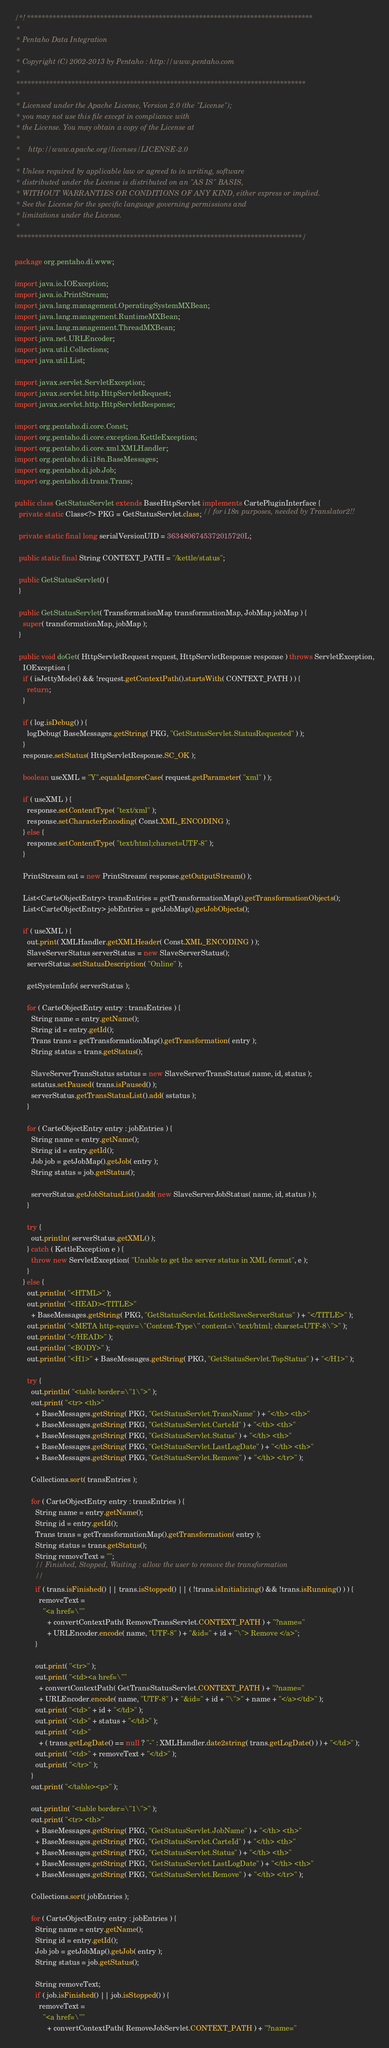<code> <loc_0><loc_0><loc_500><loc_500><_Java_>/*! ******************************************************************************
 *
 * Pentaho Data Integration
 *
 * Copyright (C) 2002-2013 by Pentaho : http://www.pentaho.com
 *
 *******************************************************************************
 *
 * Licensed under the Apache License, Version 2.0 (the "License");
 * you may not use this file except in compliance with
 * the License. You may obtain a copy of the License at
 *
 *    http://www.apache.org/licenses/LICENSE-2.0
 *
 * Unless required by applicable law or agreed to in writing, software
 * distributed under the License is distributed on an "AS IS" BASIS,
 * WITHOUT WARRANTIES OR CONDITIONS OF ANY KIND, either express or implied.
 * See the License for the specific language governing permissions and
 * limitations under the License.
 *
 ******************************************************************************/

package org.pentaho.di.www;

import java.io.IOException;
import java.io.PrintStream;
import java.lang.management.OperatingSystemMXBean;
import java.lang.management.RuntimeMXBean;
import java.lang.management.ThreadMXBean;
import java.net.URLEncoder;
import java.util.Collections;
import java.util.List;

import javax.servlet.ServletException;
import javax.servlet.http.HttpServletRequest;
import javax.servlet.http.HttpServletResponse;

import org.pentaho.di.core.Const;
import org.pentaho.di.core.exception.KettleException;
import org.pentaho.di.core.xml.XMLHandler;
import org.pentaho.di.i18n.BaseMessages;
import org.pentaho.di.job.Job;
import org.pentaho.di.trans.Trans;

public class GetStatusServlet extends BaseHttpServlet implements CartePluginInterface {
  private static Class<?> PKG = GetStatusServlet.class; // for i18n purposes, needed by Translator2!!

  private static final long serialVersionUID = 3634806745372015720L;

  public static final String CONTEXT_PATH = "/kettle/status";

  public GetStatusServlet() {
  }

  public GetStatusServlet( TransformationMap transformationMap, JobMap jobMap ) {
    super( transformationMap, jobMap );
  }

  public void doGet( HttpServletRequest request, HttpServletResponse response ) throws ServletException,
    IOException {
    if ( isJettyMode() && !request.getContextPath().startsWith( CONTEXT_PATH ) ) {
      return;
    }

    if ( log.isDebug() ) {
      logDebug( BaseMessages.getString( PKG, "GetStatusServlet.StatusRequested" ) );
    }
    response.setStatus( HttpServletResponse.SC_OK );

    boolean useXML = "Y".equalsIgnoreCase( request.getParameter( "xml" ) );

    if ( useXML ) {
      response.setContentType( "text/xml" );
      response.setCharacterEncoding( Const.XML_ENCODING );
    } else {
      response.setContentType( "text/html;charset=UTF-8" );
    }

    PrintStream out = new PrintStream( response.getOutputStream() );

    List<CarteObjectEntry> transEntries = getTransformationMap().getTransformationObjects();
    List<CarteObjectEntry> jobEntries = getJobMap().getJobObjects();

    if ( useXML ) {
      out.print( XMLHandler.getXMLHeader( Const.XML_ENCODING ) );
      SlaveServerStatus serverStatus = new SlaveServerStatus();
      serverStatus.setStatusDescription( "Online" );

      getSystemInfo( serverStatus );

      for ( CarteObjectEntry entry : transEntries ) {
        String name = entry.getName();
        String id = entry.getId();
        Trans trans = getTransformationMap().getTransformation( entry );
        String status = trans.getStatus();

        SlaveServerTransStatus sstatus = new SlaveServerTransStatus( name, id, status );
        sstatus.setPaused( trans.isPaused() );
        serverStatus.getTransStatusList().add( sstatus );
      }

      for ( CarteObjectEntry entry : jobEntries ) {
        String name = entry.getName();
        String id = entry.getId();
        Job job = getJobMap().getJob( entry );
        String status = job.getStatus();

        serverStatus.getJobStatusList().add( new SlaveServerJobStatus( name, id, status ) );
      }

      try {
        out.println( serverStatus.getXML() );
      } catch ( KettleException e ) {
        throw new ServletException( "Unable to get the server status in XML format", e );
      }
    } else {
      out.println( "<HTML>" );
      out.println( "<HEAD><TITLE>"
        + BaseMessages.getString( PKG, "GetStatusServlet.KettleSlaveServerStatus" ) + "</TITLE>" );
      out.println( "<META http-equiv=\"Content-Type\" content=\"text/html; charset=UTF-8\">" );
      out.println( "</HEAD>" );
      out.println( "<BODY>" );
      out.println( "<H1>" + BaseMessages.getString( PKG, "GetStatusServlet.TopStatus" ) + "</H1>" );

      try {
        out.println( "<table border=\"1\">" );
        out.print( "<tr> <th>"
          + BaseMessages.getString( PKG, "GetStatusServlet.TransName" ) + "</th> <th>"
          + BaseMessages.getString( PKG, "GetStatusServlet.CarteId" ) + "</th> <th>"
          + BaseMessages.getString( PKG, "GetStatusServlet.Status" ) + "</th> <th>"
          + BaseMessages.getString( PKG, "GetStatusServlet.LastLogDate" ) + "</th> <th>"
          + BaseMessages.getString( PKG, "GetStatusServlet.Remove" ) + "</th> </tr>" );

        Collections.sort( transEntries );

        for ( CarteObjectEntry entry : transEntries ) {
          String name = entry.getName();
          String id = entry.getId();
          Trans trans = getTransformationMap().getTransformation( entry );
          String status = trans.getStatus();
          String removeText = "";
          // Finished, Stopped, Waiting : allow the user to remove the transformation
          //
          if ( trans.isFinished() || trans.isStopped() || ( !trans.isInitializing() && !trans.isRunning() ) ) {
            removeText =
              "<a href=\""
                + convertContextPath( RemoveTransServlet.CONTEXT_PATH ) + "?name="
                + URLEncoder.encode( name, "UTF-8" ) + "&id=" + id + "\"> Remove </a>";
          }

          out.print( "<tr>" );
          out.print( "<td><a href=\""
            + convertContextPath( GetTransStatusServlet.CONTEXT_PATH ) + "?name="
            + URLEncoder.encode( name, "UTF-8" ) + "&id=" + id + "\">" + name + "</a></td>" );
          out.print( "<td>" + id + "</td>" );
          out.print( "<td>" + status + "</td>" );
          out.print( "<td>"
            + ( trans.getLogDate() == null ? "-" : XMLHandler.date2string( trans.getLogDate() ) ) + "</td>" );
          out.print( "<td>" + removeText + "</td>" );
          out.print( "</tr>" );
        }
        out.print( "</table><p>" );

        out.println( "<table border=\"1\">" );
        out.print( "<tr> <th>"
          + BaseMessages.getString( PKG, "GetStatusServlet.JobName" ) + "</th> <th>"
          + BaseMessages.getString( PKG, "GetStatusServlet.CarteId" ) + "</th> <th>"
          + BaseMessages.getString( PKG, "GetStatusServlet.Status" ) + "</th> <th>"
          + BaseMessages.getString( PKG, "GetStatusServlet.LastLogDate" ) + "</th> <th>"
          + BaseMessages.getString( PKG, "GetStatusServlet.Remove" ) + "</th> </tr>" );

        Collections.sort( jobEntries );

        for ( CarteObjectEntry entry : jobEntries ) {
          String name = entry.getName();
          String id = entry.getId();
          Job job = getJobMap().getJob( entry );
          String status = job.getStatus();

          String removeText;
          if ( job.isFinished() || job.isStopped() ) {
            removeText =
              "<a href=\""
                + convertContextPath( RemoveJobServlet.CONTEXT_PATH ) + "?name="</code> 